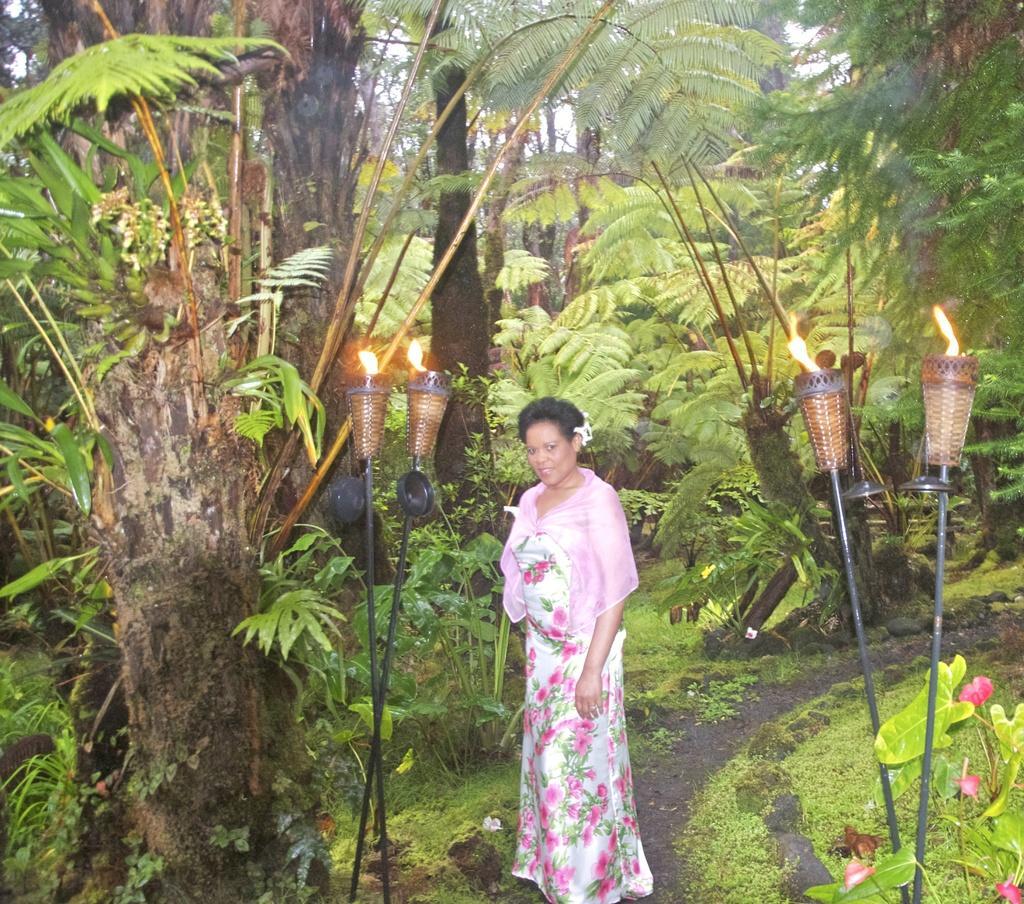How would you summarize this image in a sentence or two? In this image in the middle, there is a woman, she wears a pink dress. On the right there are trees, plants, grass, lights, sticks. On the left there are trees, lights, sticks, plants and grass. 